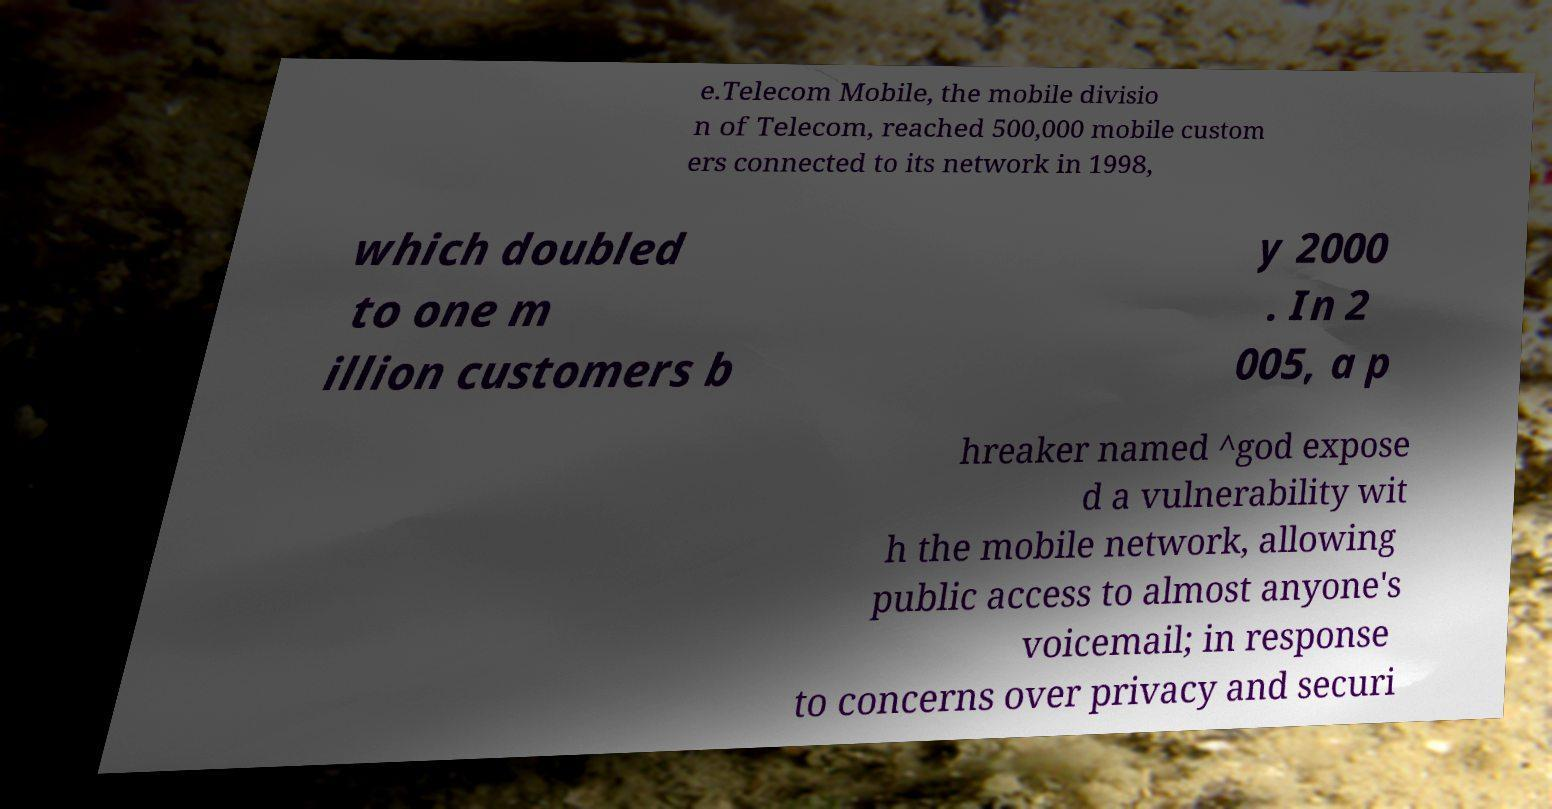I need the written content from this picture converted into text. Can you do that? e.Telecom Mobile, the mobile divisio n of Telecom, reached 500,000 mobile custom ers connected to its network in 1998, which doubled to one m illion customers b y 2000 . In 2 005, a p hreaker named ^god expose d a vulnerability wit h the mobile network, allowing public access to almost anyone's voicemail; in response to concerns over privacy and securi 